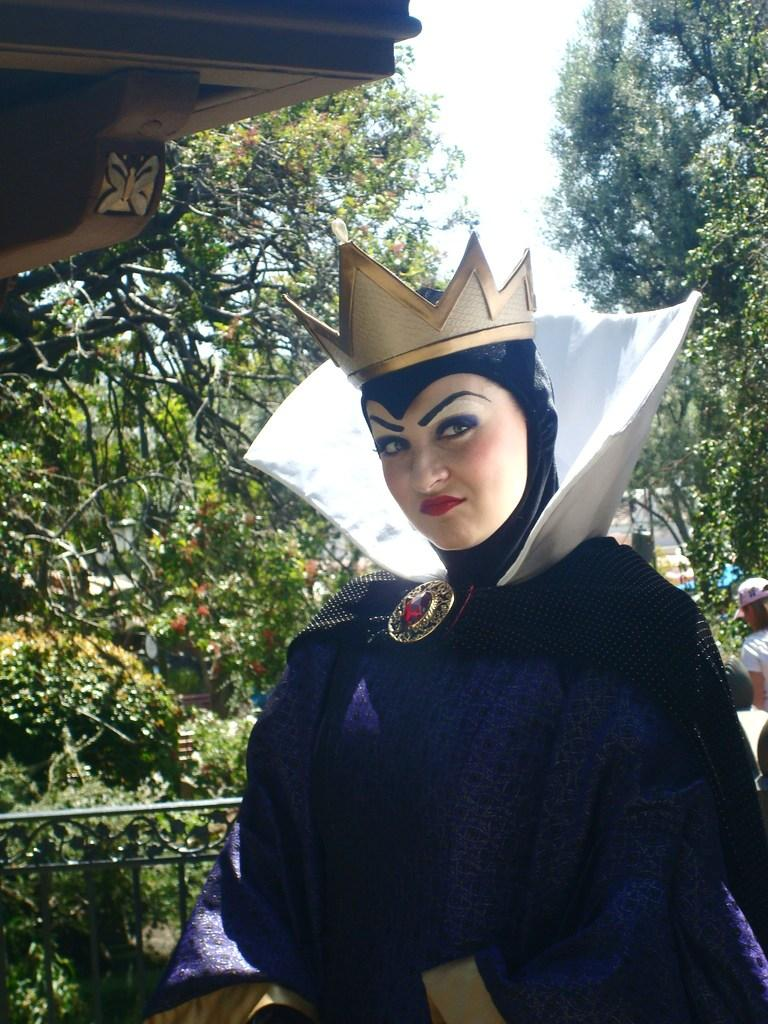How many people are in the image? There are two persons in the image. Can you describe the costumes of the people in the image? One of the persons is wearing a different costume, and they are wearing a crown. What type of natural elements can be seen in the image? There are plants and trees in the image. What architectural features are present in the image? There is a railing and a slab in the image. What is visible in the sky in the image? The sky is visible in the image. What type of breakfast is being prepared in the oven in the image? There is no oven or breakfast present in the image. Can you describe the hand gestures of the people in the image? The provided facts do not mention any hand gestures of the people in the image. 